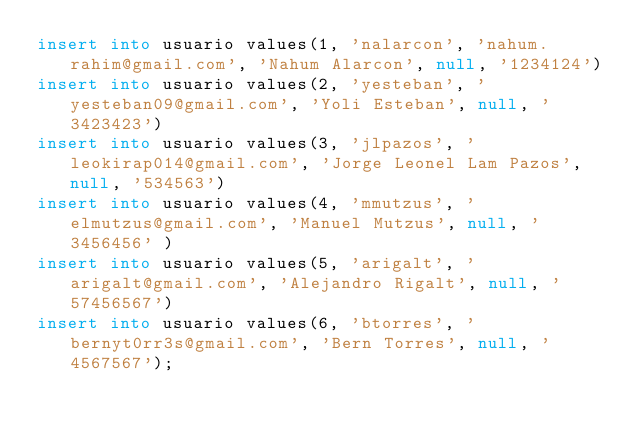<code> <loc_0><loc_0><loc_500><loc_500><_SQL_>insert into usuario values(1, 'nalarcon', 'nahum.rahim@gmail.com', 'Nahum Alarcon', null, '1234124')
insert into usuario values(2, 'yesteban', 'yesteban09@gmail.com', 'Yoli Esteban', null, '3423423')
insert into usuario values(3, 'jlpazos', 'leokirap014@gmail.com', 'Jorge Leonel Lam Pazos', null, '534563')
insert into usuario values(4, 'mmutzus', 'elmutzus@gmail.com', 'Manuel Mutzus', null, '3456456' )
insert into usuario values(5, 'arigalt', 'arigalt@gmail.com', 'Alejandro Rigalt', null, '57456567')
insert into usuario values(6, 'btorres', 'bernyt0rr3s@gmail.com', 'Bern Torres', null, '4567567');
</code> 